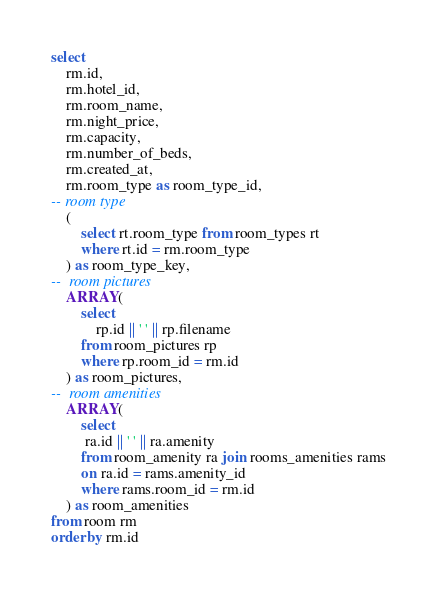<code> <loc_0><loc_0><loc_500><loc_500><_SQL_>select
	rm.id,
	rm.hotel_id,
	rm.room_name,
	rm.night_price,
	rm.capacity,
	rm.number_of_beds,
	rm.created_at,
	rm.room_type as room_type_id,
-- room type
	( 
		select rt.room_type from room_types rt
		where rt.id = rm.room_type
	) as room_type_key,
-- 	room pictures
	ARRAY(
		select 
			rp.id || ' ' || rp.filename
		from room_pictures rp
		where rp.room_id = rm.id
	) as room_pictures,
-- 	room amenities
	ARRAY(
		select 
		 ra.id || ' ' || ra.amenity
		from room_amenity ra join rooms_amenities rams
		on ra.id = rams.amenity_id
		where rams.room_id = rm.id
	) as room_amenities
from room rm 
order by rm.id</code> 